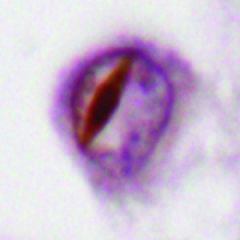re these cancers associated with neuronal intranuclear inclusions containing tdp43?
Answer the question using a single word or phrase. No 